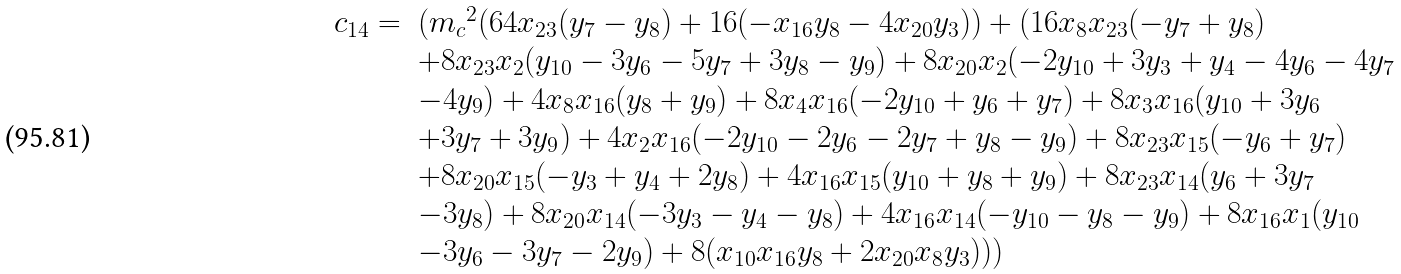Convert formula to latex. <formula><loc_0><loc_0><loc_500><loc_500>\begin{array} { l l } c _ { 1 4 } = & ( { m _ { c } } ^ { 2 } ( 6 4 x _ { 2 3 } ( y _ { 7 } - y _ { 8 } ) + 1 6 ( - x _ { 1 6 } y _ { 8 } - 4 x _ { 2 0 } y _ { 3 } ) ) + ( 1 6 x _ { 8 } x _ { 2 3 } ( - y _ { 7 } + y _ { 8 } ) \\ & + 8 x _ { 2 3 } x _ { 2 } ( y _ { 1 0 } - 3 y _ { 6 } - 5 y _ { 7 } + 3 y _ { 8 } - y _ { 9 } ) + 8 x _ { 2 0 } x _ { 2 } ( - 2 y _ { 1 0 } + 3 y _ { 3 } + y _ { 4 } - 4 y _ { 6 } - 4 y _ { 7 } \\ & - 4 y _ { 9 } ) + 4 x _ { 8 } x _ { 1 6 } ( y _ { 8 } + y _ { 9 } ) + 8 x _ { 4 } x _ { 1 6 } ( - 2 y _ { 1 0 } + y _ { 6 } + y _ { 7 } ) + 8 x _ { 3 } x _ { 1 6 } ( y _ { 1 0 } + 3 y _ { 6 } \\ & + 3 y _ { 7 } + 3 y _ { 9 } ) + 4 x _ { 2 } x _ { 1 6 } ( - 2 y _ { 1 0 } - 2 y _ { 6 } - 2 y _ { 7 } + y _ { 8 } - y _ { 9 } ) + 8 x _ { 2 3 } x _ { 1 5 } ( - y _ { 6 } + y _ { 7 } ) \\ & + 8 x _ { 2 0 } x _ { 1 5 } ( - y _ { 3 } + y _ { 4 } + 2 y _ { 8 } ) + 4 x _ { 1 6 } x _ { 1 5 } ( y _ { 1 0 } + y _ { 8 } + y _ { 9 } ) + 8 x _ { 2 3 } x _ { 1 4 } ( y _ { 6 } + 3 y _ { 7 } \\ & - 3 y _ { 8 } ) + 8 x _ { 2 0 } x _ { 1 4 } ( - 3 y _ { 3 } - y _ { 4 } - y _ { 8 } ) + 4 x _ { 1 6 } x _ { 1 4 } ( - y _ { 1 0 } - y _ { 8 } - y _ { 9 } ) + 8 x _ { 1 6 } x _ { 1 } ( y _ { 1 0 } \\ & - 3 y _ { 6 } - 3 y _ { 7 } - 2 y _ { 9 } ) + 8 ( x _ { 1 0 } x _ { 1 6 } y _ { 8 } + 2 x _ { 2 0 } x _ { 8 } y _ { 3 } ) ) ) \end{array}</formula> 